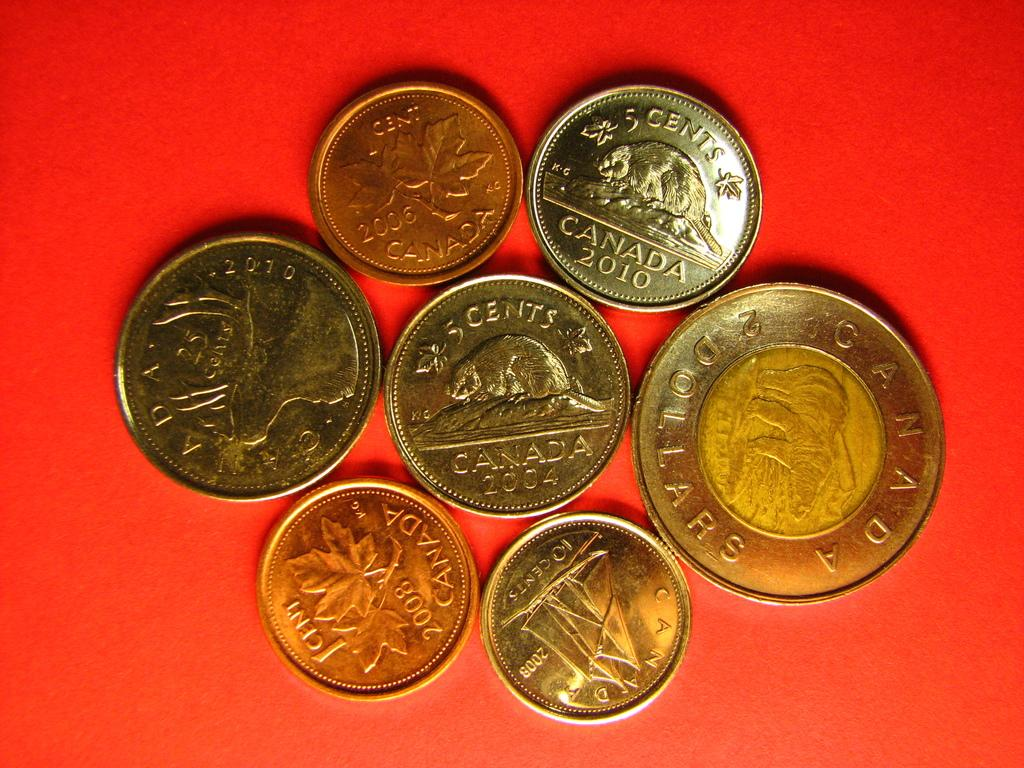<image>
Provide a brief description of the given image. Various Canadian coins laying on a red surface. 